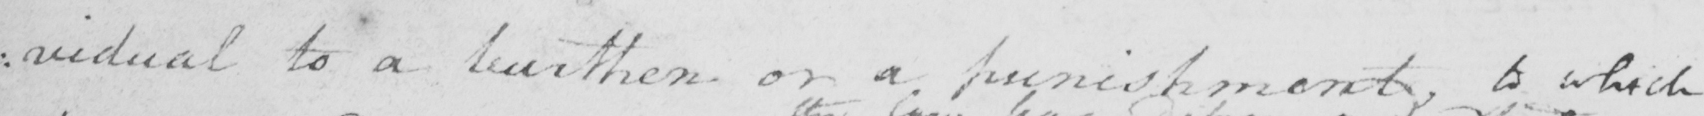Please transcribe the handwritten text in this image. : vidual to a burthen or a punishment , to which 